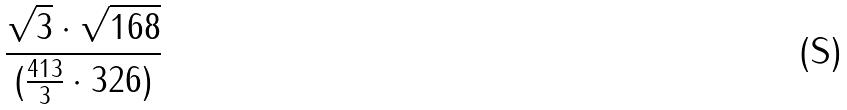Convert formula to latex. <formula><loc_0><loc_0><loc_500><loc_500>\frac { \sqrt { 3 } \cdot \sqrt { 1 6 8 } } { ( \frac { 4 1 3 } { 3 } \cdot 3 2 6 ) }</formula> 